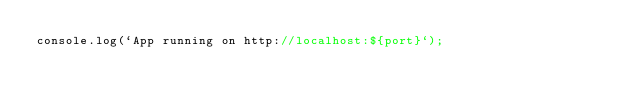Convert code to text. <code><loc_0><loc_0><loc_500><loc_500><_JavaScript_>console.log(`App running on http://localhost:${port}`);
</code> 